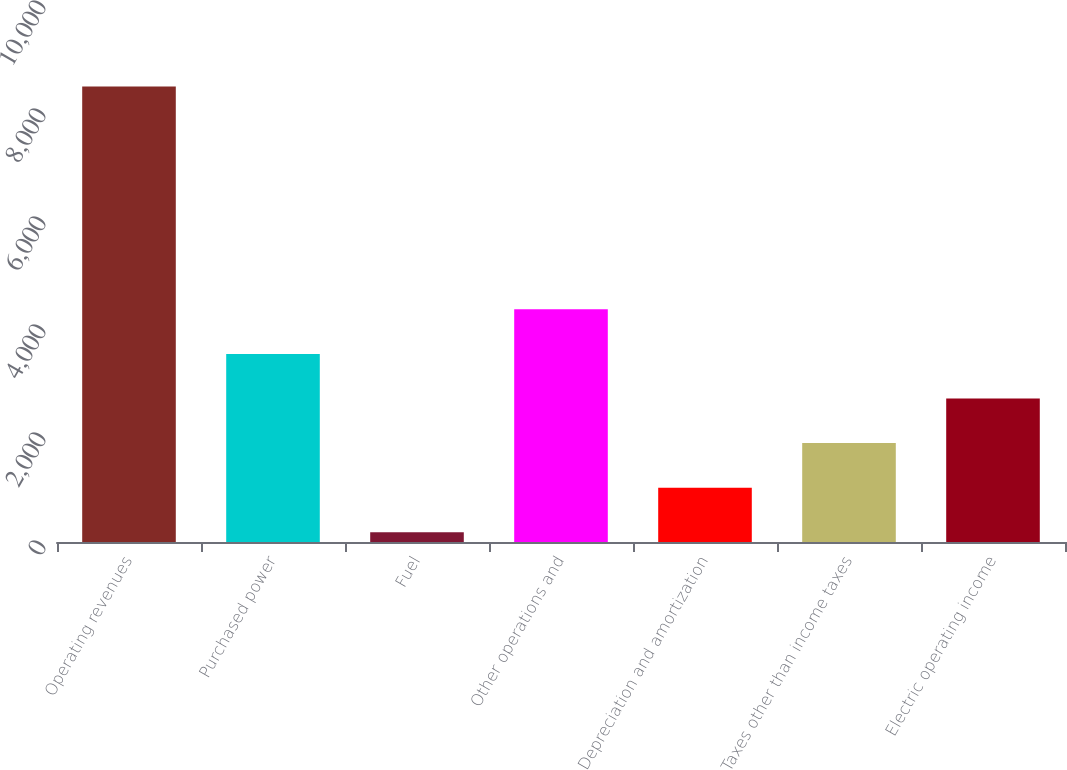<chart> <loc_0><loc_0><loc_500><loc_500><bar_chart><fcel>Operating revenues<fcel>Purchased power<fcel>Fuel<fcel>Other operations and<fcel>Depreciation and amortization<fcel>Taxes other than income taxes<fcel>Electric operating income<nl><fcel>8437<fcel>3482.8<fcel>180<fcel>4308.5<fcel>1005.7<fcel>1831.4<fcel>2657.1<nl></chart> 